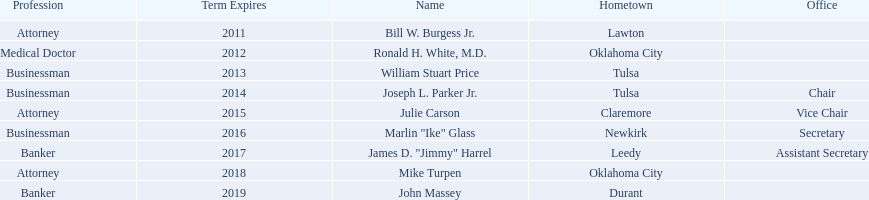Where is bill w. burgess jr. from? Lawton. Where is price and parker from? Tulsa. Who is from the same state as white? Mike Turpen. 